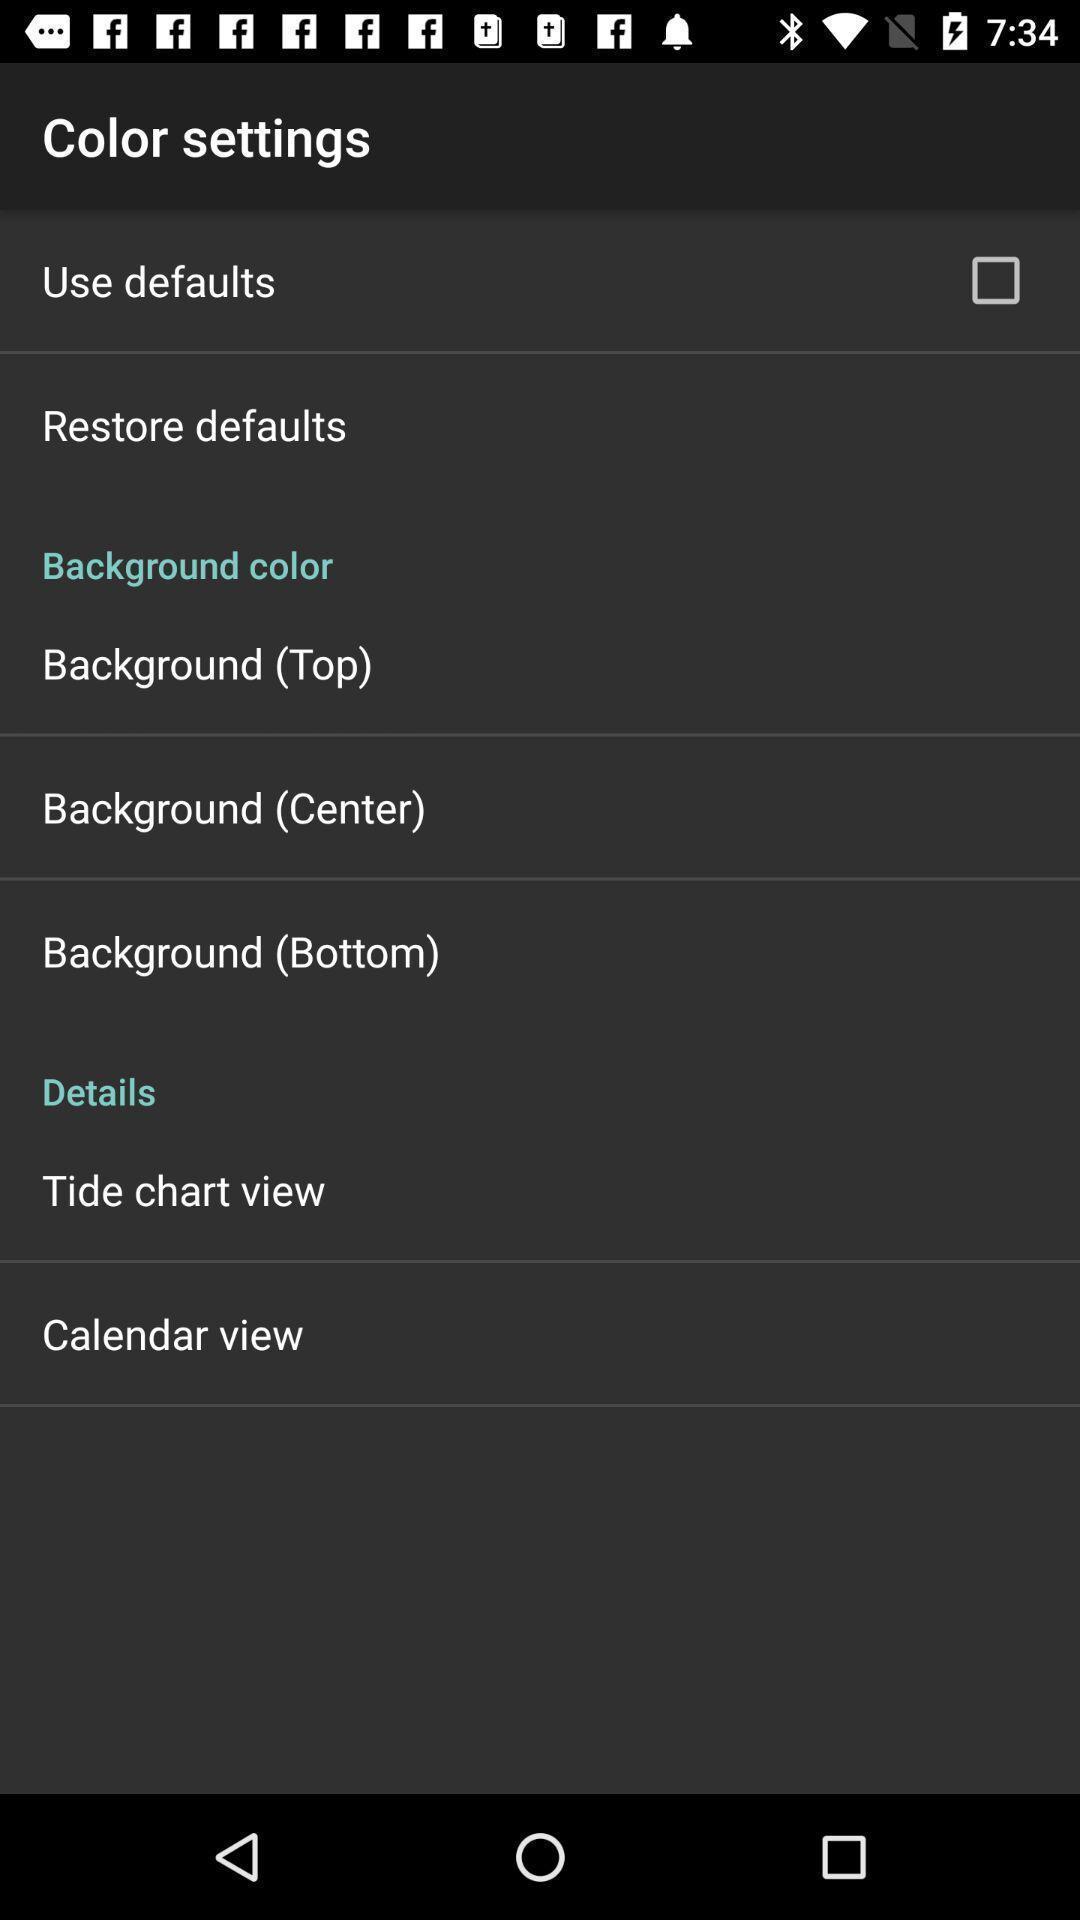Explain what's happening in this screen capture. Screen showing about color settings. 